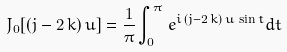Convert formula to latex. <formula><loc_0><loc_0><loc_500><loc_500>J _ { 0 } [ ( j - 2 \, k ) \, u ] = \frac { 1 } { \pi } \int _ { 0 } ^ { \pi } \, e ^ { i \, ( j - 2 \, k ) \, u \, \sin t } d t</formula> 